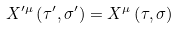<formula> <loc_0><loc_0><loc_500><loc_500>X ^ { \prime \mu } \left ( \tau ^ { \prime } , \sigma ^ { \prime } \right ) = X ^ { \mu } \left ( \tau , \sigma \right )</formula> 